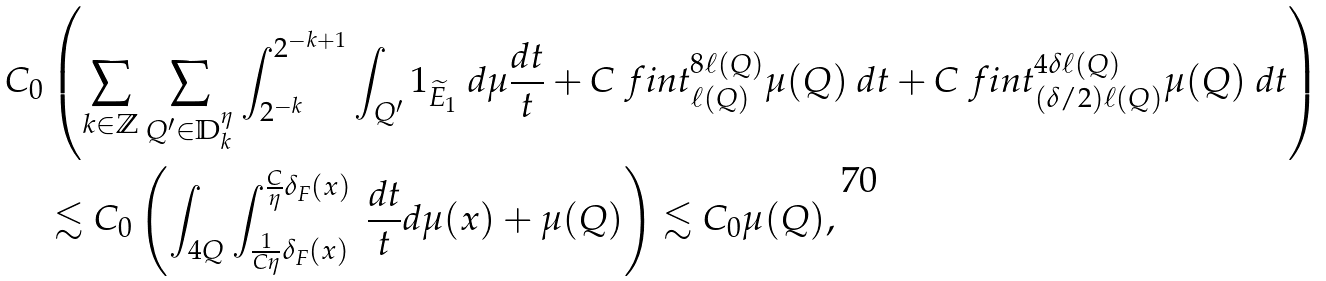Convert formula to latex. <formula><loc_0><loc_0><loc_500><loc_500>C _ { 0 } & \left ( \sum _ { k \in \mathbb { Z } } \sum _ { Q ^ { \prime } \in \mathbb { D } _ { k } ^ { \eta } } \int _ { 2 ^ { - k } } ^ { 2 ^ { - k + 1 } } \int _ { Q ^ { \prime } } \mathbb { m } { 1 } _ { \widetilde { E } _ { 1 } } \ d \mu \frac { d t } { t } + C \ f i n t _ { \ell ( Q ) } ^ { 8 \ell ( Q ) } \mu ( Q ) \ d t + C \ f i n t _ { ( \delta / 2 ) \ell ( Q ) } ^ { 4 \delta \ell ( Q ) } \mu ( Q ) \ d t \right ) \\ & \lesssim C _ { 0 } \left ( \int _ { 4 Q } \int _ { \frac { 1 } { C \eta } \delta _ { F } ( x ) } ^ { \frac { C } { \eta } \delta _ { F } ( x ) } \ \frac { d t } { t } d \mu ( x ) + \mu ( Q ) \right ) \lesssim C _ { 0 } \mu ( Q ) ,</formula> 